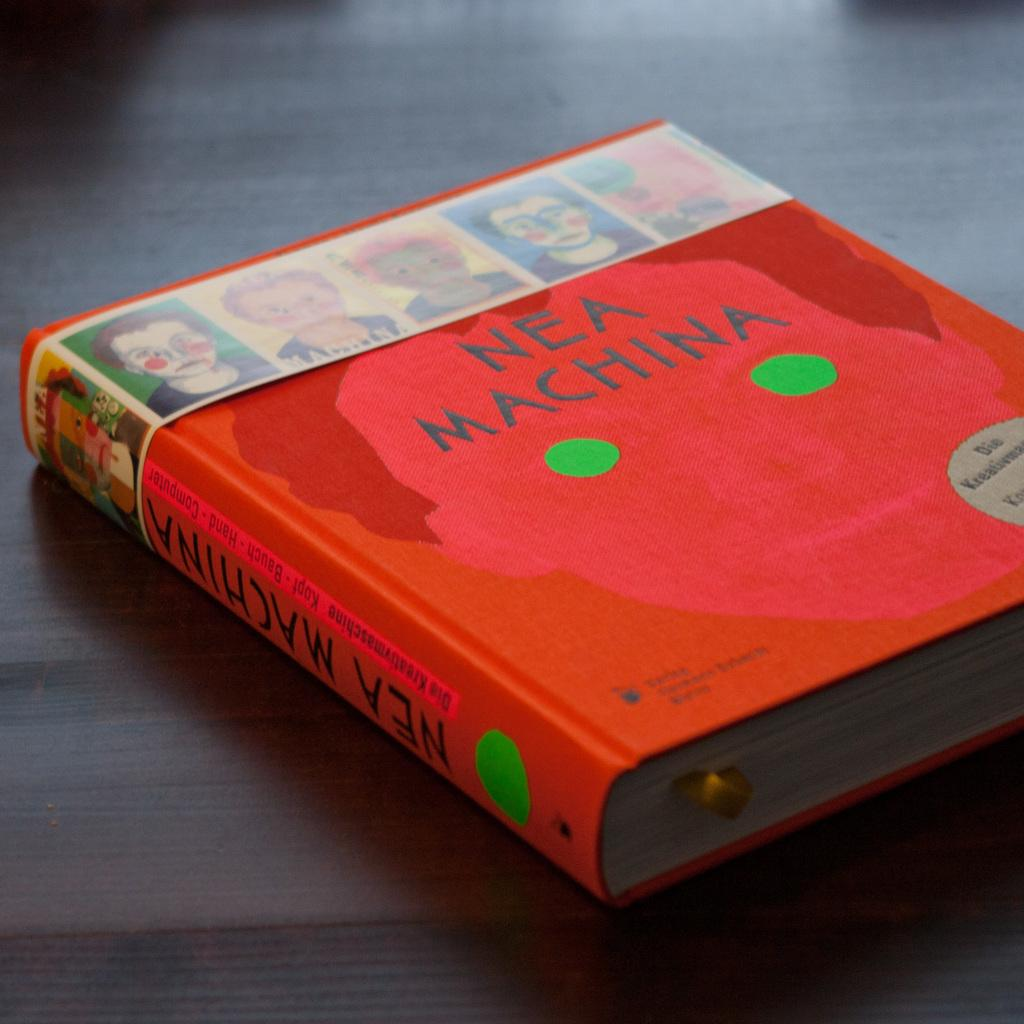<image>
Offer a succinct explanation of the picture presented. Book laying on the table with a face with green eyes by NEA Machina 